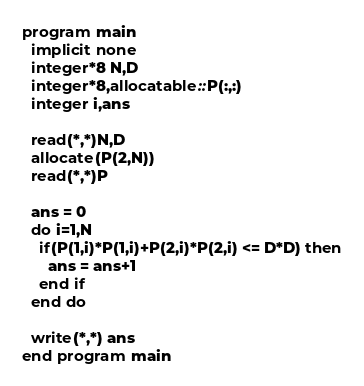Convert code to text. <code><loc_0><loc_0><loc_500><loc_500><_FORTRAN_>program main
  implicit none
  integer*8 N,D
  integer*8,allocatable::P(:,:)
  integer i,ans
  
  read(*,*)N,D
  allocate(P(2,N))
  read(*,*)P
  
  ans = 0
  do i=1,N
    if(P(1,i)*P(1,i)+P(2,i)*P(2,i) <= D*D) then
      ans = ans+1
    end if
  end do
  
  write(*,*) ans
end program main</code> 